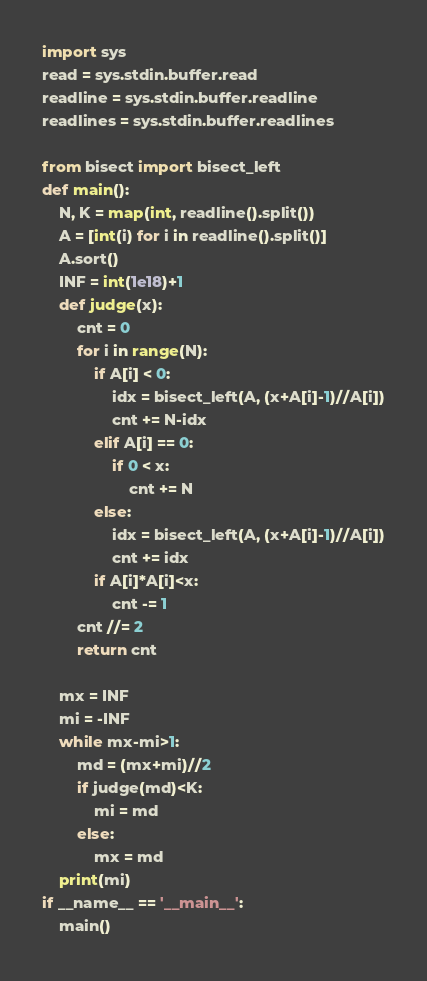<code> <loc_0><loc_0><loc_500><loc_500><_Python_>import sys
read = sys.stdin.buffer.read
readline = sys.stdin.buffer.readline
readlines = sys.stdin.buffer.readlines

from bisect import bisect_left 
def main():
    N, K = map(int, readline().split())
    A = [int(i) for i in readline().split()]
    A.sort()
    INF = int(1e18)+1
    def judge(x):
        cnt = 0
        for i in range(N):
            if A[i] < 0:
                idx = bisect_left(A, (x+A[i]-1)//A[i])
                cnt += N-idx
            elif A[i] == 0:  
                if 0 < x:
                    cnt += N
            else:
                idx = bisect_left(A, (x+A[i]-1)//A[i])
                cnt += idx  
            if A[i]*A[i]<x:
                cnt -= 1
        cnt //= 2
        return cnt

    mx = INF
    mi = -INF
    while mx-mi>1:
        md = (mx+mi)//2
        if judge(md)<K:
            mi = md
        else:
            mx = md
    print(mi)
if __name__ == '__main__':
    main()
</code> 